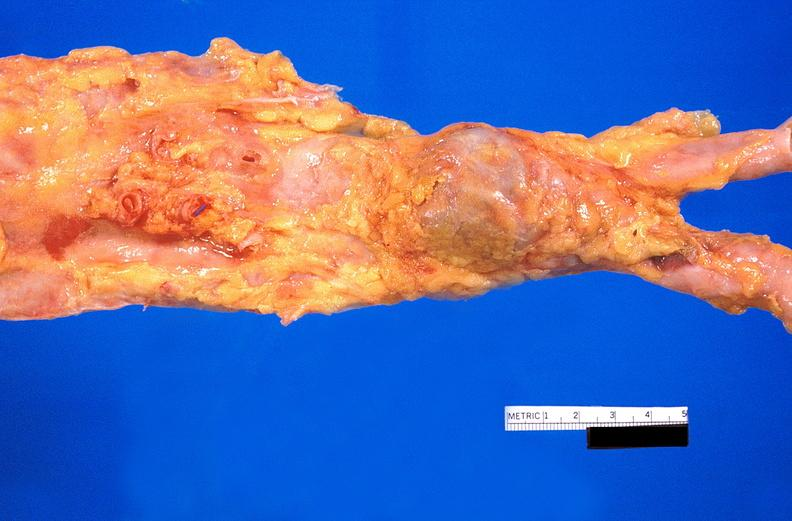s cardiovascular present?
Answer the question using a single word or phrase. Yes 